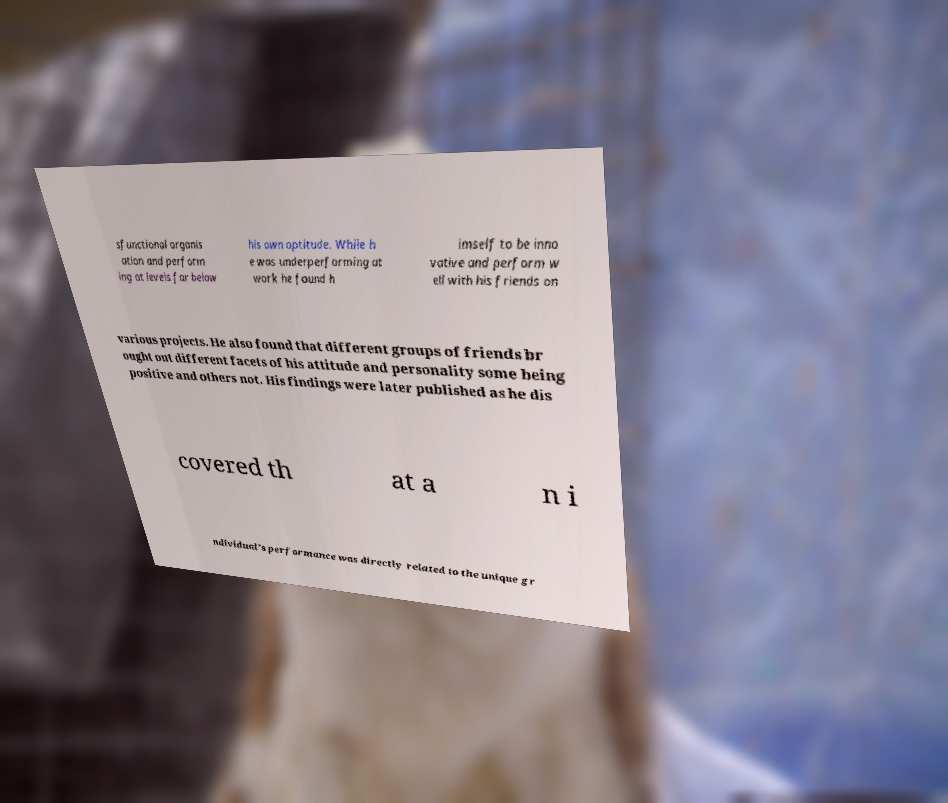There's text embedded in this image that I need extracted. Can you transcribe it verbatim? sfunctional organis ation and perform ing at levels far below his own aptitude. While h e was underperforming at work he found h imself to be inno vative and perform w ell with his friends on various projects. He also found that different groups of friends br ought out different facets of his attitude and personality some being positive and others not. His findings were later published as he dis covered th at a n i ndividual’s performance was directly related to the unique gr 